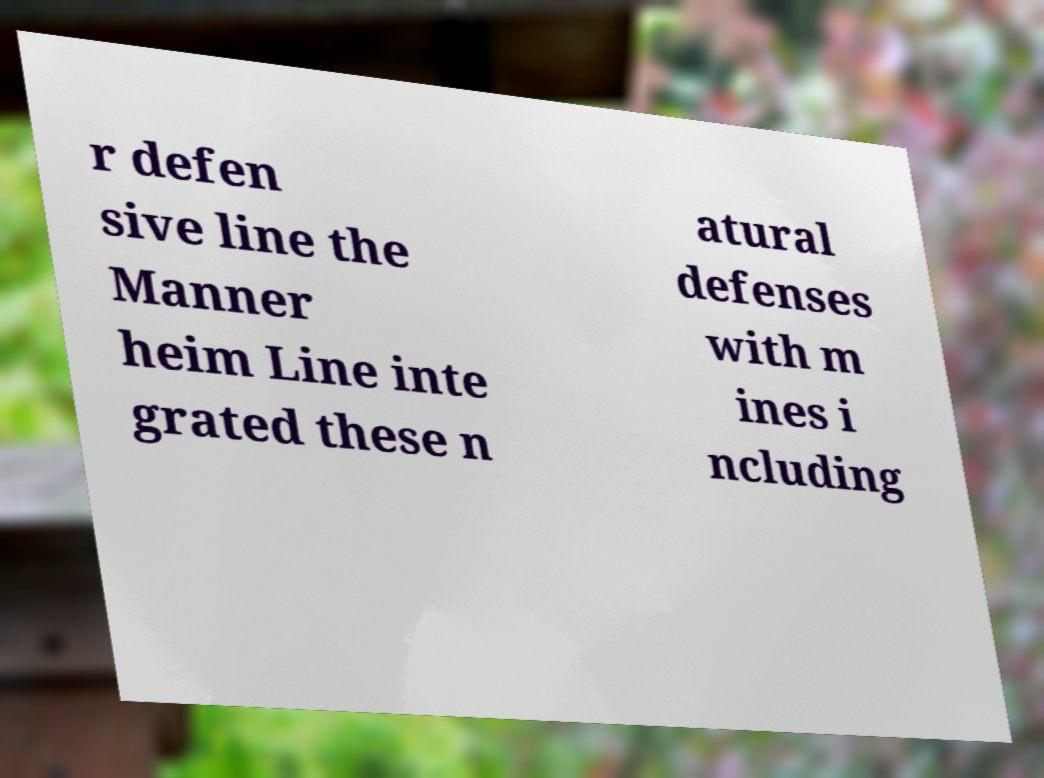For documentation purposes, I need the text within this image transcribed. Could you provide that? r defen sive line the Manner heim Line inte grated these n atural defenses with m ines i ncluding 